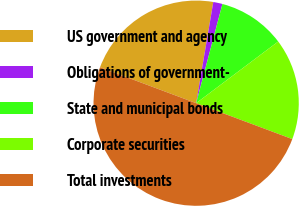Convert chart to OTSL. <chart><loc_0><loc_0><loc_500><loc_500><pie_chart><fcel>US government and agency<fcel>Obligations of government-<fcel>State and municipal bonds<fcel>Corporate securities<fcel>Total investments<nl><fcel>21.98%<fcel>1.45%<fcel>10.62%<fcel>15.95%<fcel>50.0%<nl></chart> 